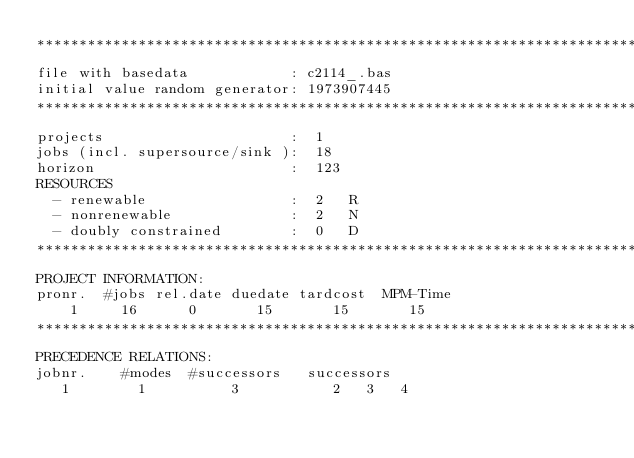Convert code to text. <code><loc_0><loc_0><loc_500><loc_500><_ObjectiveC_>************************************************************************
file with basedata            : c2114_.bas
initial value random generator: 1973907445
************************************************************************
projects                      :  1
jobs (incl. supersource/sink ):  18
horizon                       :  123
RESOURCES
  - renewable                 :  2   R
  - nonrenewable              :  2   N
  - doubly constrained        :  0   D
************************************************************************
PROJECT INFORMATION:
pronr.  #jobs rel.date duedate tardcost  MPM-Time
    1     16      0       15       15       15
************************************************************************
PRECEDENCE RELATIONS:
jobnr.    #modes  #successors   successors
   1        1          3           2   3   4</code> 